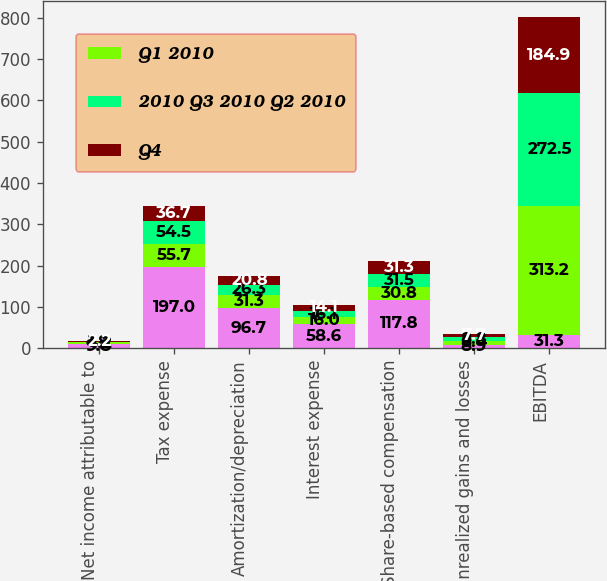Convert chart to OTSL. <chart><loc_0><loc_0><loc_500><loc_500><stacked_bar_chart><ecel><fcel>Net income attributable to<fcel>Tax expense<fcel>Amortization/depreciation<fcel>Interest expense<fcel>Share-based compensation<fcel>Unrealized gains and losses<fcel>EBITDA<nl><fcel>nan<fcel>9.8<fcel>197<fcel>96.7<fcel>58.6<fcel>117.8<fcel>8.9<fcel>31.3<nl><fcel>Q1 2010<fcel>4.2<fcel>55.7<fcel>31.3<fcel>16<fcel>30.8<fcel>8.4<fcel>313.2<nl><fcel>2010 Q3 2010 Q2 2010<fcel>1.8<fcel>54.5<fcel>26.3<fcel>16.1<fcel>31.5<fcel>8.8<fcel>272.5<nl><fcel>Q4<fcel>2.2<fcel>36.7<fcel>20.8<fcel>14.1<fcel>31.3<fcel>7.7<fcel>184.9<nl></chart> 